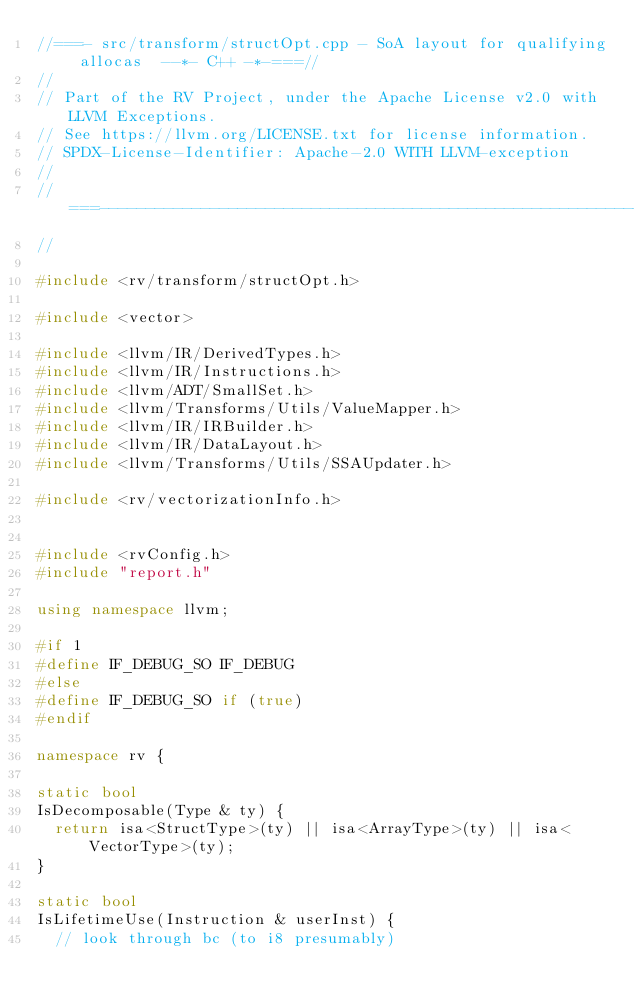<code> <loc_0><loc_0><loc_500><loc_500><_C++_>//===- src/transform/structOpt.cpp - SoA layout for qualifying allocas  --*- C++ -*-===//
//
// Part of the RV Project, under the Apache License v2.0 with LLVM Exceptions.
// See https://llvm.org/LICENSE.txt for license information.
// SPDX-License-Identifier: Apache-2.0 WITH LLVM-exception
//
//===----------------------------------------------------------------------===//
//

#include <rv/transform/structOpt.h>

#include <vector>

#include <llvm/IR/DerivedTypes.h>
#include <llvm/IR/Instructions.h>
#include <llvm/ADT/SmallSet.h>
#include <llvm/Transforms/Utils/ValueMapper.h>
#include <llvm/IR/IRBuilder.h>
#include <llvm/IR/DataLayout.h>
#include <llvm/Transforms/Utils/SSAUpdater.h>

#include <rv/vectorizationInfo.h>


#include <rvConfig.h>
#include "report.h"

using namespace llvm;

#if 1
#define IF_DEBUG_SO IF_DEBUG
#else
#define IF_DEBUG_SO if (true)
#endif

namespace rv {

static bool
IsDecomposable(Type & ty) {
  return isa<StructType>(ty) || isa<ArrayType>(ty) || isa<VectorType>(ty);
}

static bool
IsLifetimeUse(Instruction & userInst) {
  // look through bc (to i8 presumably)</code> 